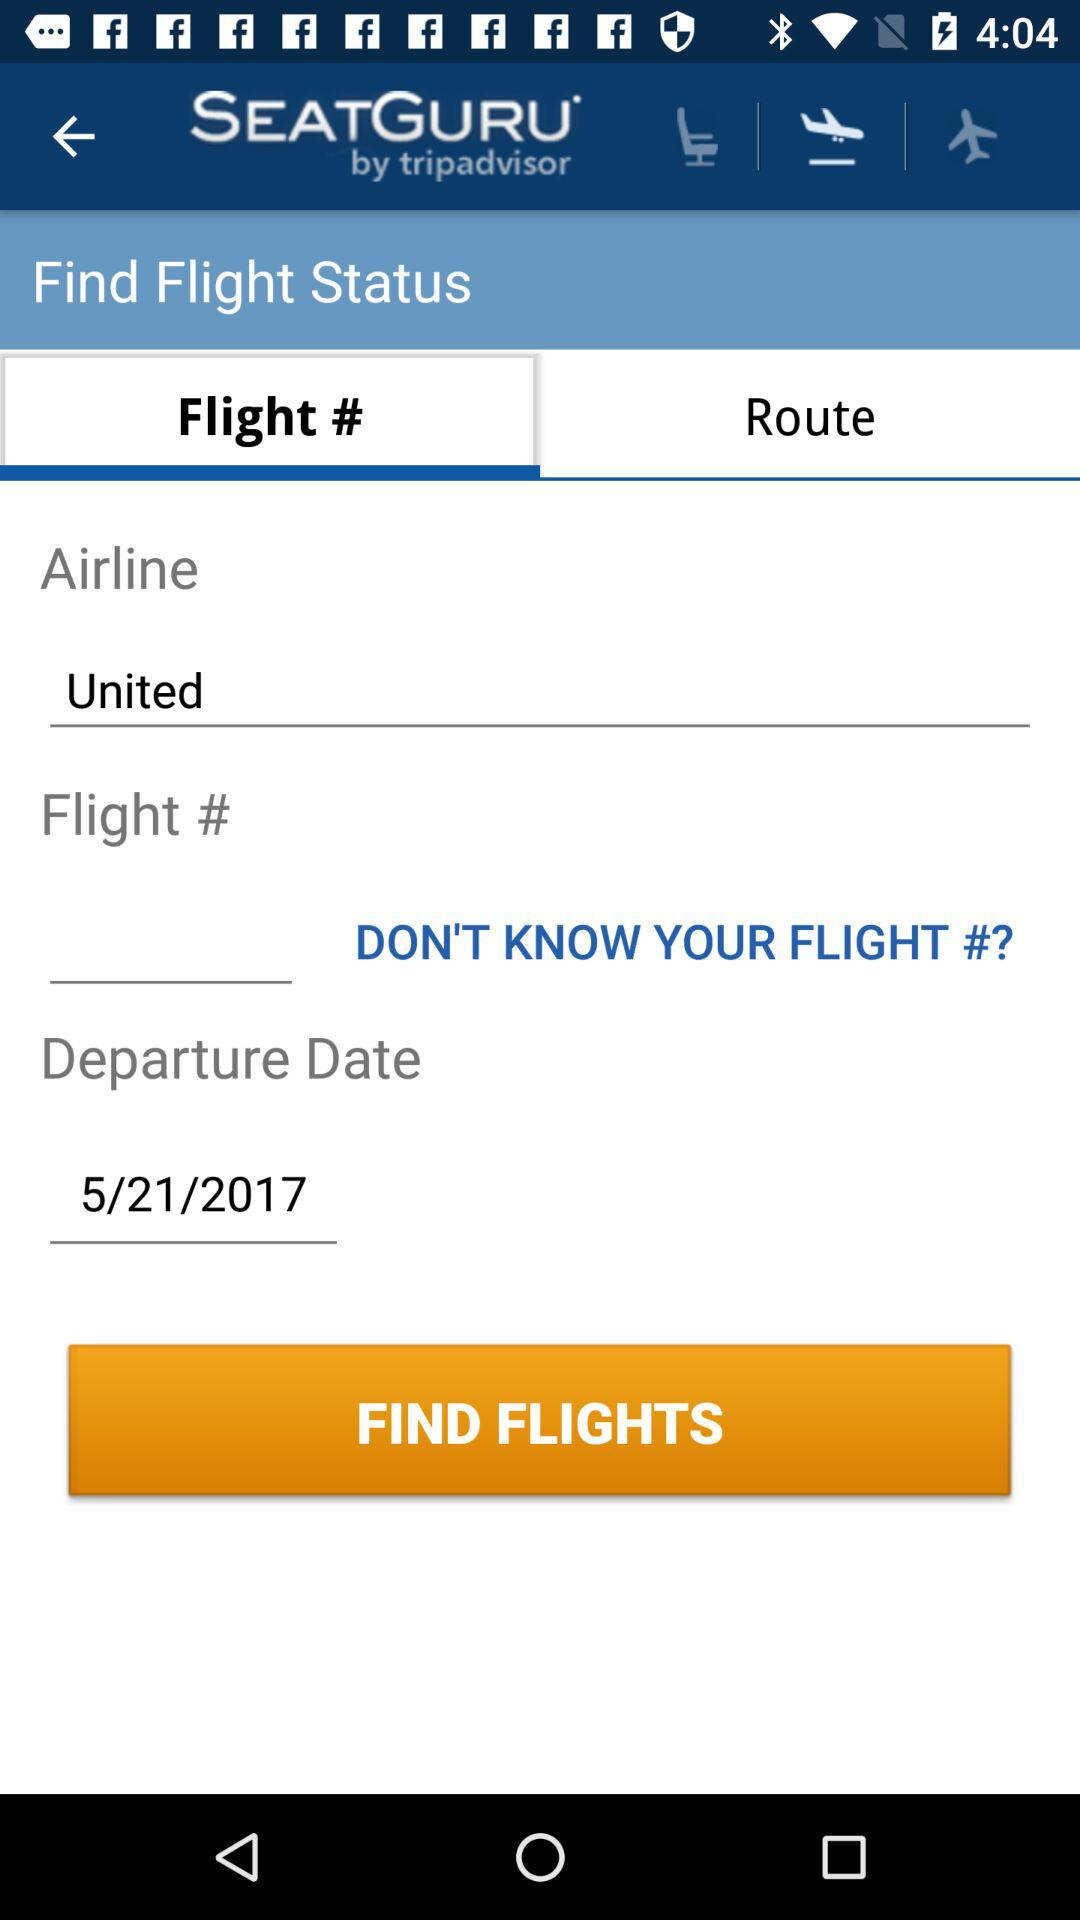Which tab is selected? The selected tab is "Flight #". 